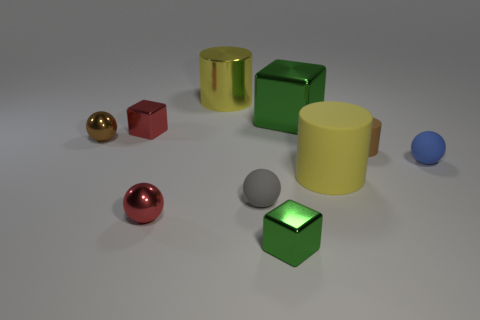Subtract all red spheres. How many yellow cylinders are left? 2 Subtract all yellow cylinders. How many cylinders are left? 1 Subtract all blue balls. How many balls are left? 3 Subtract all balls. How many objects are left? 6 Subtract all gray blocks. Subtract all gray spheres. How many blocks are left? 3 Subtract 1 red cubes. How many objects are left? 9 Subtract all cyan metallic blocks. Subtract all tiny green metal blocks. How many objects are left? 9 Add 6 tiny metallic things. How many tiny metallic things are left? 10 Add 1 gray metal balls. How many gray metal balls exist? 1 